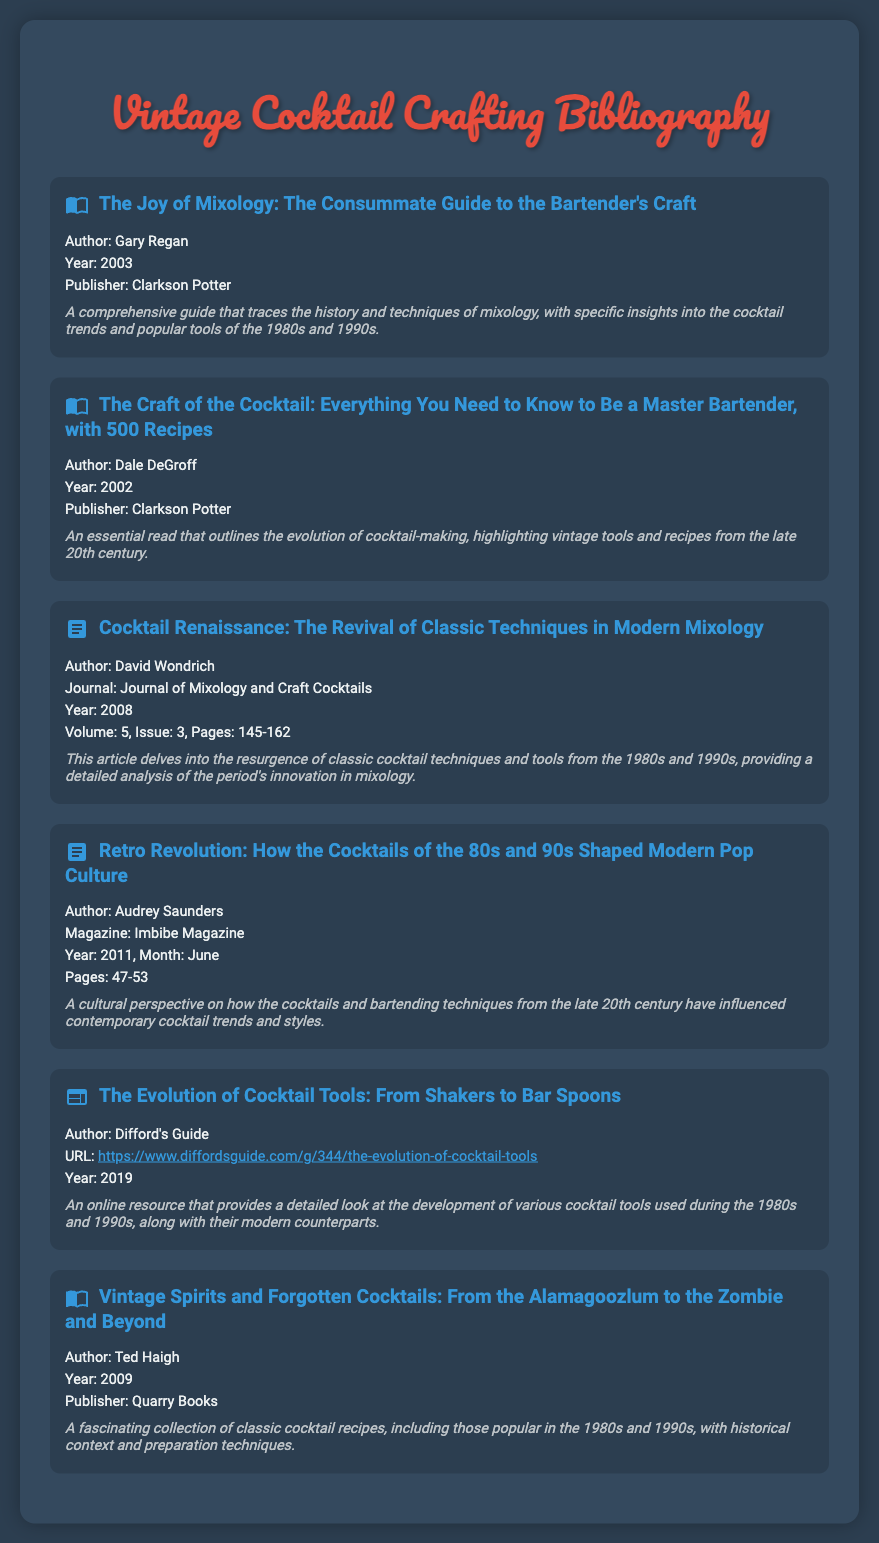What is the title of the first item in the bibliography? The title of the first item can be found at the top of the first bibliography entry, which is "The Joy of Mixology: The Consummate Guide to the Bartender's Craft".
Answer: The Joy of Mixology: The Consummate Guide to the Bartender's Craft Who is the author of "The Craft of the Cocktail"? The author's name is listed under the corresponding bibliography entry for "The Craft of the Cocktail".
Answer: Dale DeGroff What year was "Cocktail Renaissance" published? The year is specified in the bibliography entry for "Cocktail Renaissance".
Answer: 2008 Which publication featured the article "Retro Revolution"? The specific magazine where the article was published is mentioned in the bibliography entry for "Retro Revolution".
Answer: Imbibe Magazine How many pages does the article "Cocktail Renaissance" cover? The range of pages is indicated in the citation for "Cocktail Renaissance".
Answer: 145-162 What kind of resource is "The Evolution of Cocktail Tools"? The type of resource is indicated in the bibliography, which specifies it as an online resource.
Answer: Online resource What is the publication year of "Vintage Spirits and Forgotten Cocktails"? The year can be found in the relevant bibliography entry for "Vintage Spirits and Forgotten Cocktails."
Answer: 2009 